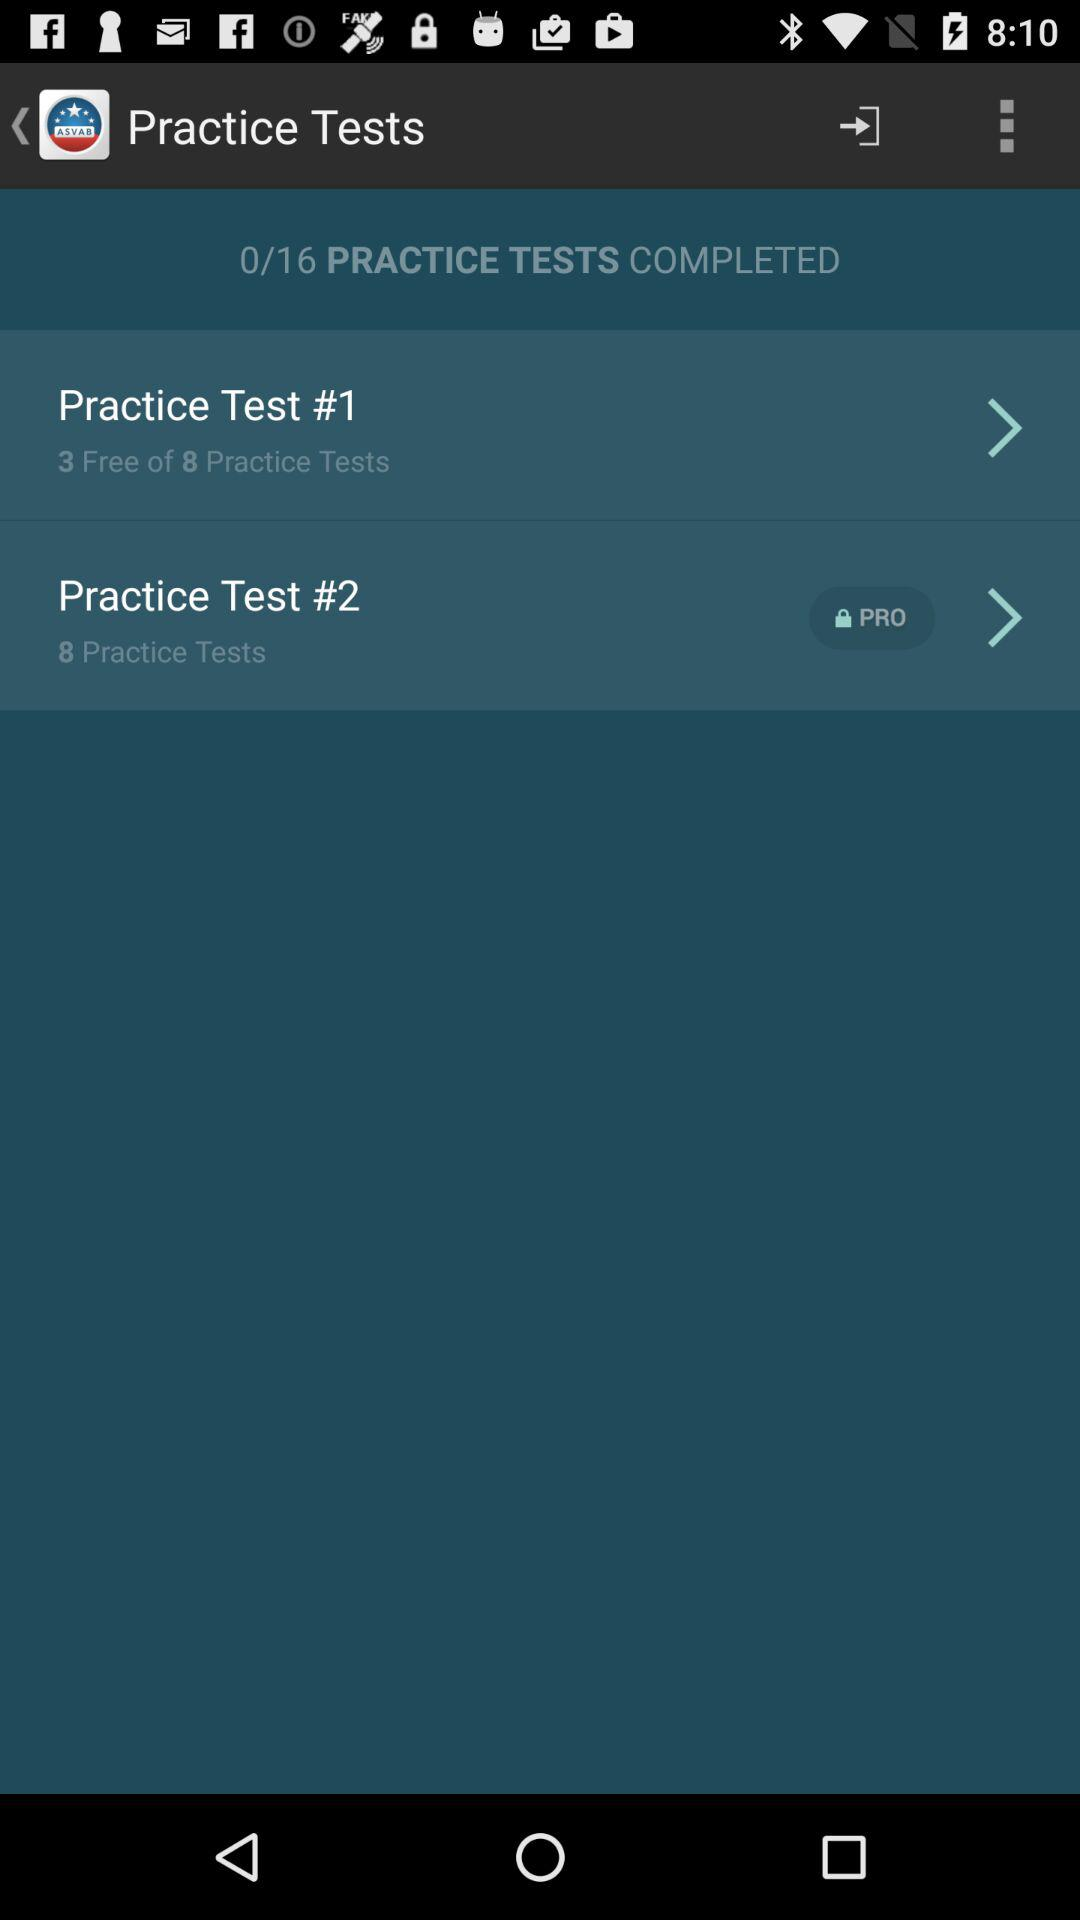How many free tests are in "Practice Test #1"? There are 3 free in "Practice Test #1". 